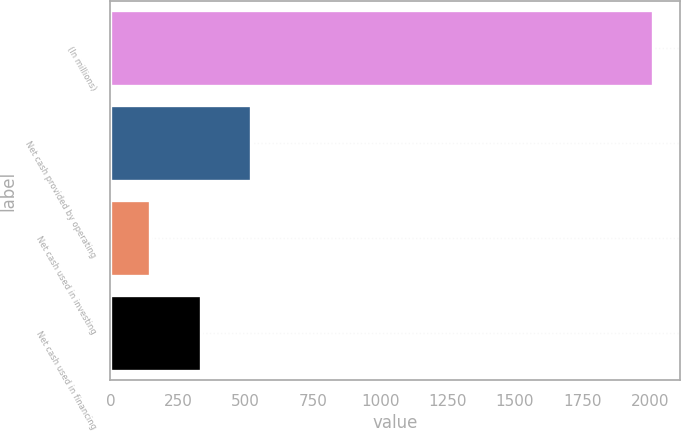<chart> <loc_0><loc_0><loc_500><loc_500><bar_chart><fcel>(In millions)<fcel>Net cash provided by operating<fcel>Net cash used in investing<fcel>Net cash used in financing<nl><fcel>2011<fcel>520.44<fcel>147.8<fcel>334.12<nl></chart> 